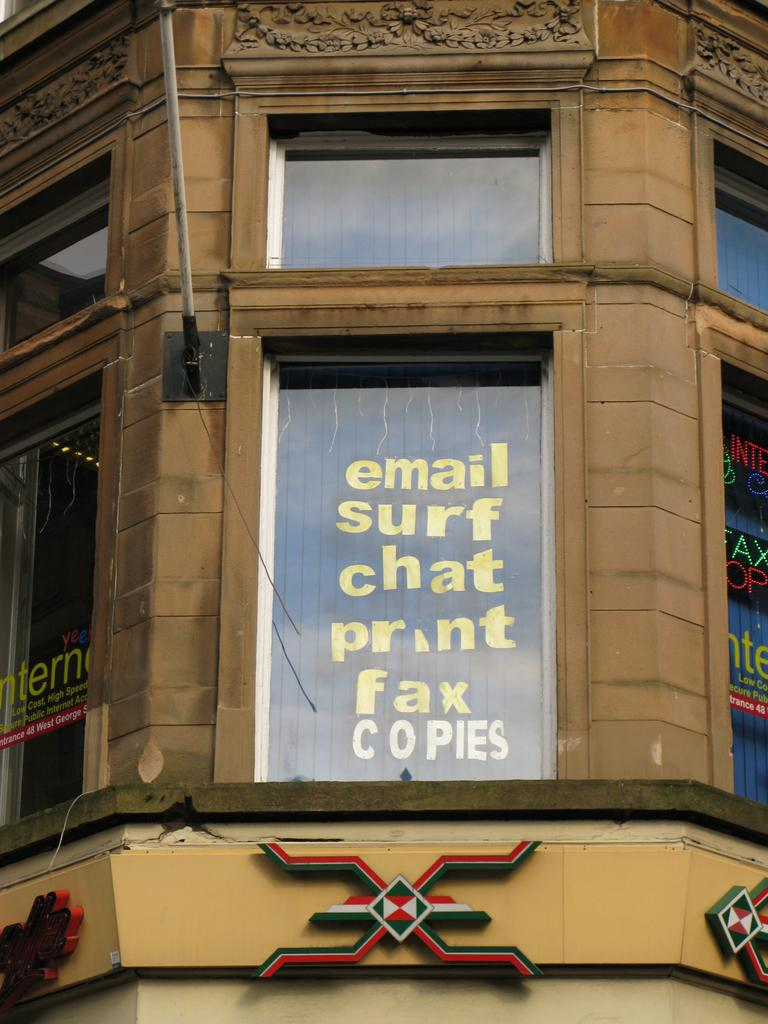What type of structure is present in the image? There is a building in the image. What feature can be observed on the building? The building has glass windows. What type of minister is seen leading a group of worms in the image? There is no minister or worms present in the image; it only features a building with glass windows. 